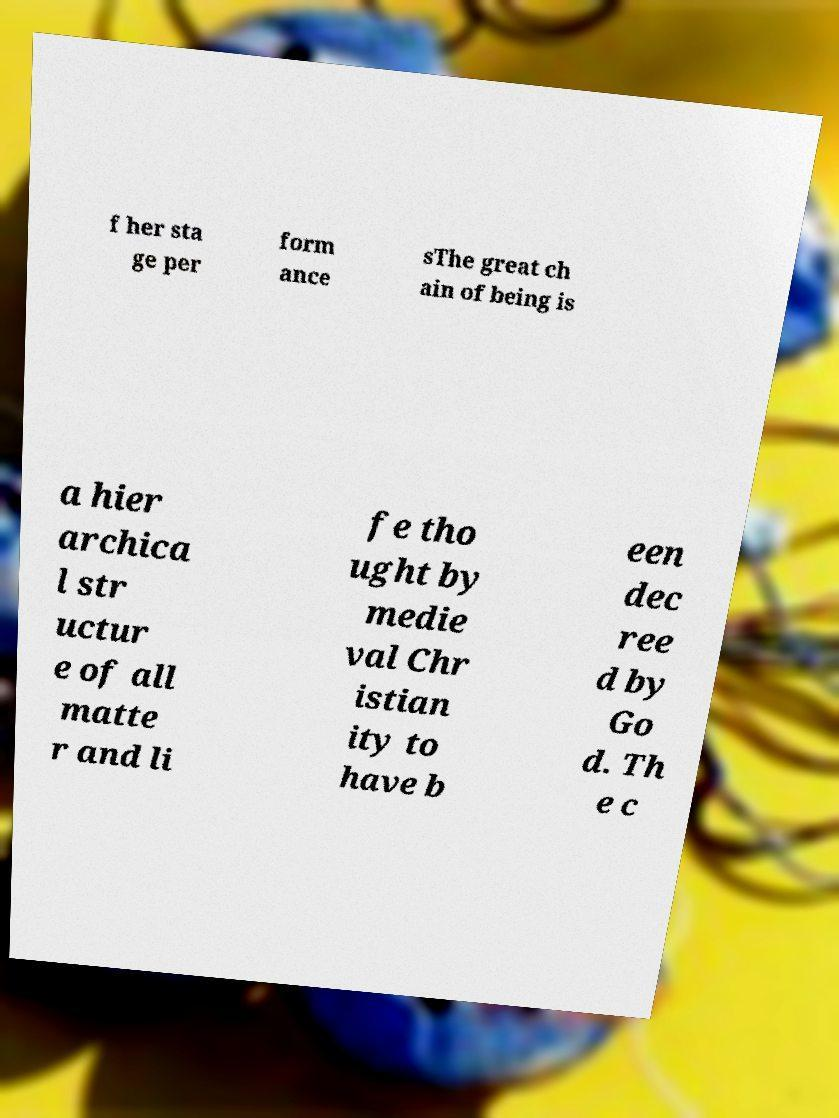For documentation purposes, I need the text within this image transcribed. Could you provide that? f her sta ge per form ance sThe great ch ain of being is a hier archica l str uctur e of all matte r and li fe tho ught by medie val Chr istian ity to have b een dec ree d by Go d. Th e c 